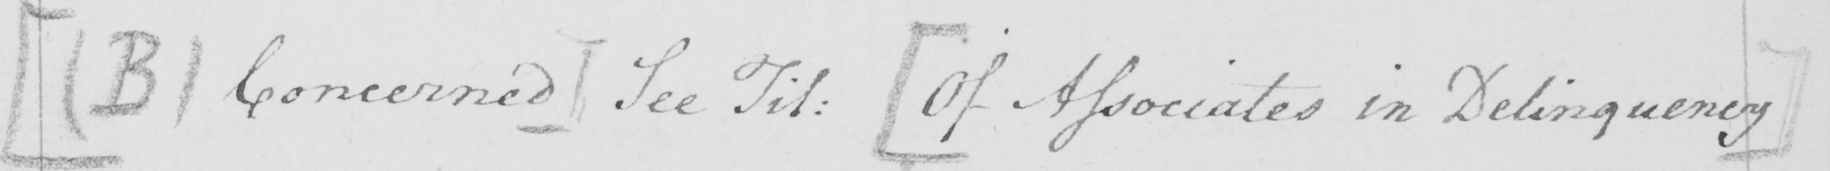Please provide the text content of this handwritten line. [  ( B ) Concerned ]  See Til :   [ Of Associates in Delinquency ] 